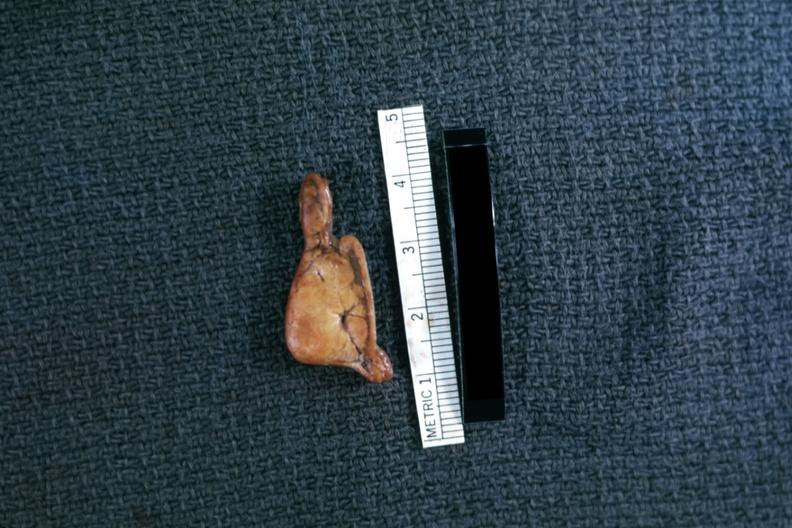does intraductal papillomatosis with apocrine metaplasia show fixed tissue but very good example in cross section?
Answer the question using a single word or phrase. No 